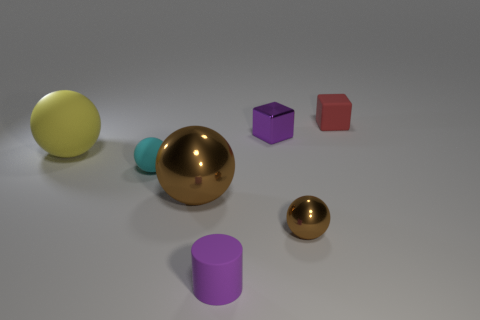There is a cylinder that is the same color as the tiny metal block; what is it made of?
Make the answer very short. Rubber. What number of other things are the same color as the small metal ball?
Your answer should be very brief. 1. There is a matte sphere in front of the big yellow matte sphere; is its size the same as the brown metallic ball that is on the left side of the small purple cube?
Provide a succinct answer. No. There is a cube that is in front of the rubber object behind the shiny cube; how big is it?
Give a very brief answer. Small. What is the tiny object that is left of the small metallic ball and behind the large yellow thing made of?
Provide a succinct answer. Metal. The tiny metallic cube has what color?
Offer a terse response. Purple. What is the shape of the small rubber thing that is in front of the small cyan matte sphere?
Your answer should be very brief. Cylinder. There is a small block that is in front of the rubber object that is behind the tiny purple block; is there a red cube that is in front of it?
Keep it short and to the point. No. Are there any other things that are the same shape as the tiny purple matte thing?
Give a very brief answer. No. Is there a large green matte thing?
Ensure brevity in your answer.  No. 